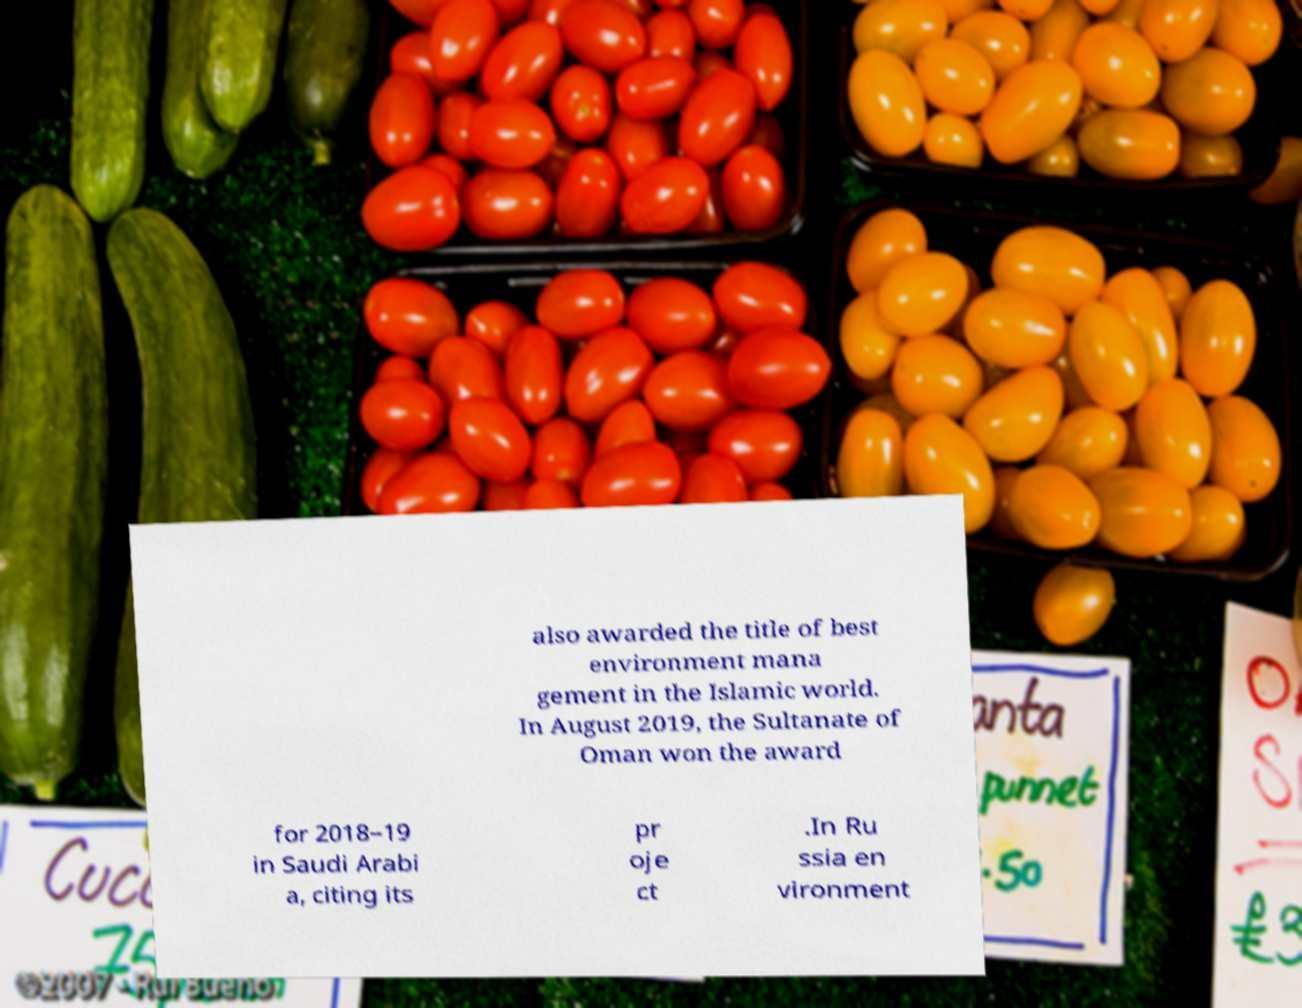I need the written content from this picture converted into text. Can you do that? also awarded the title of best environment mana gement in the Islamic world. In August 2019, the Sultanate of Oman won the award for 2018–19 in Saudi Arabi a, citing its pr oje ct .In Ru ssia en vironment 